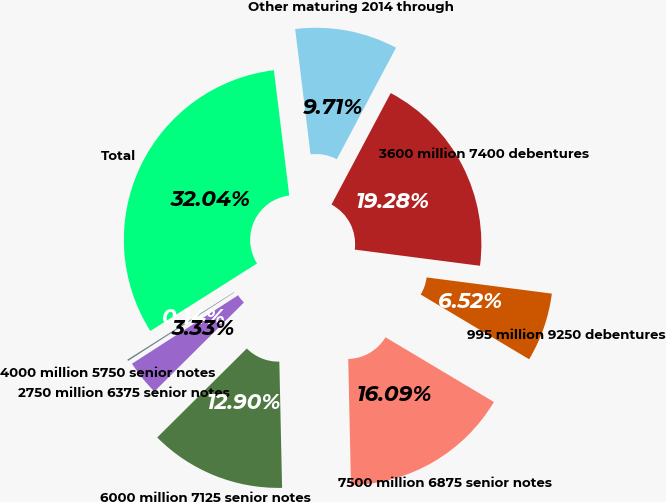Convert chart. <chart><loc_0><loc_0><loc_500><loc_500><pie_chart><fcel>4000 million 5750 senior notes<fcel>2750 million 6375 senior notes<fcel>6000 million 7125 senior notes<fcel>7500 million 6875 senior notes<fcel>995 million 9250 debentures<fcel>3600 million 7400 debentures<fcel>Other maturing 2014 through<fcel>Total<nl><fcel>0.14%<fcel>3.33%<fcel>12.9%<fcel>16.09%<fcel>6.52%<fcel>19.28%<fcel>9.71%<fcel>32.04%<nl></chart> 